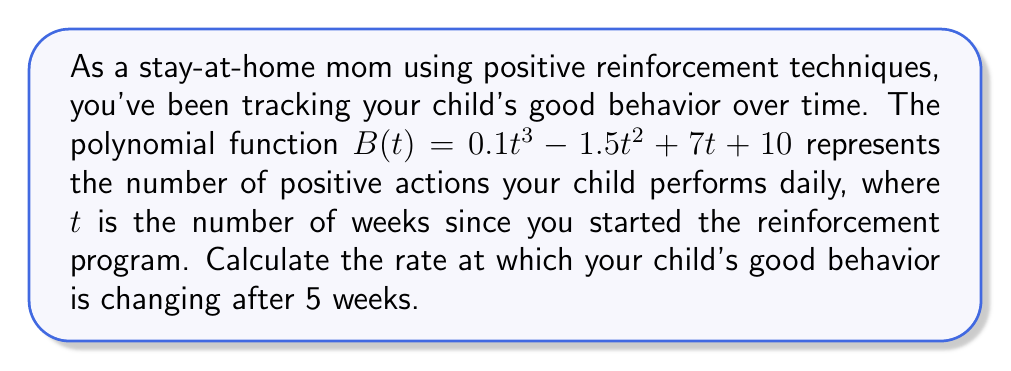What is the answer to this math problem? To solve this problem, we need to follow these steps:

1) The rate of change is represented by the derivative of the function. So, we need to find $B'(t)$.

2) To find $B'(t)$, we use the power rule of differentiation:
   $$B'(t) = 0.3t^2 - 3t + 7$$

3) Now that we have the derivative, we can find the rate of change at any point by plugging in the t-value.

4) We're asked about the rate of change after 5 weeks, so we need to calculate $B'(5)$:

   $$B'(5) = 0.3(5)^2 - 3(5) + 7$$
   $$= 0.3(25) - 15 + 7$$
   $$= 7.5 - 15 + 7$$
   $$= -0.5$$

5) The negative value indicates that the rate of change is decreasing at this point.
Answer: The rate at which the child's good behavior is changing after 5 weeks is $-0.5$ positive actions per day per week. 